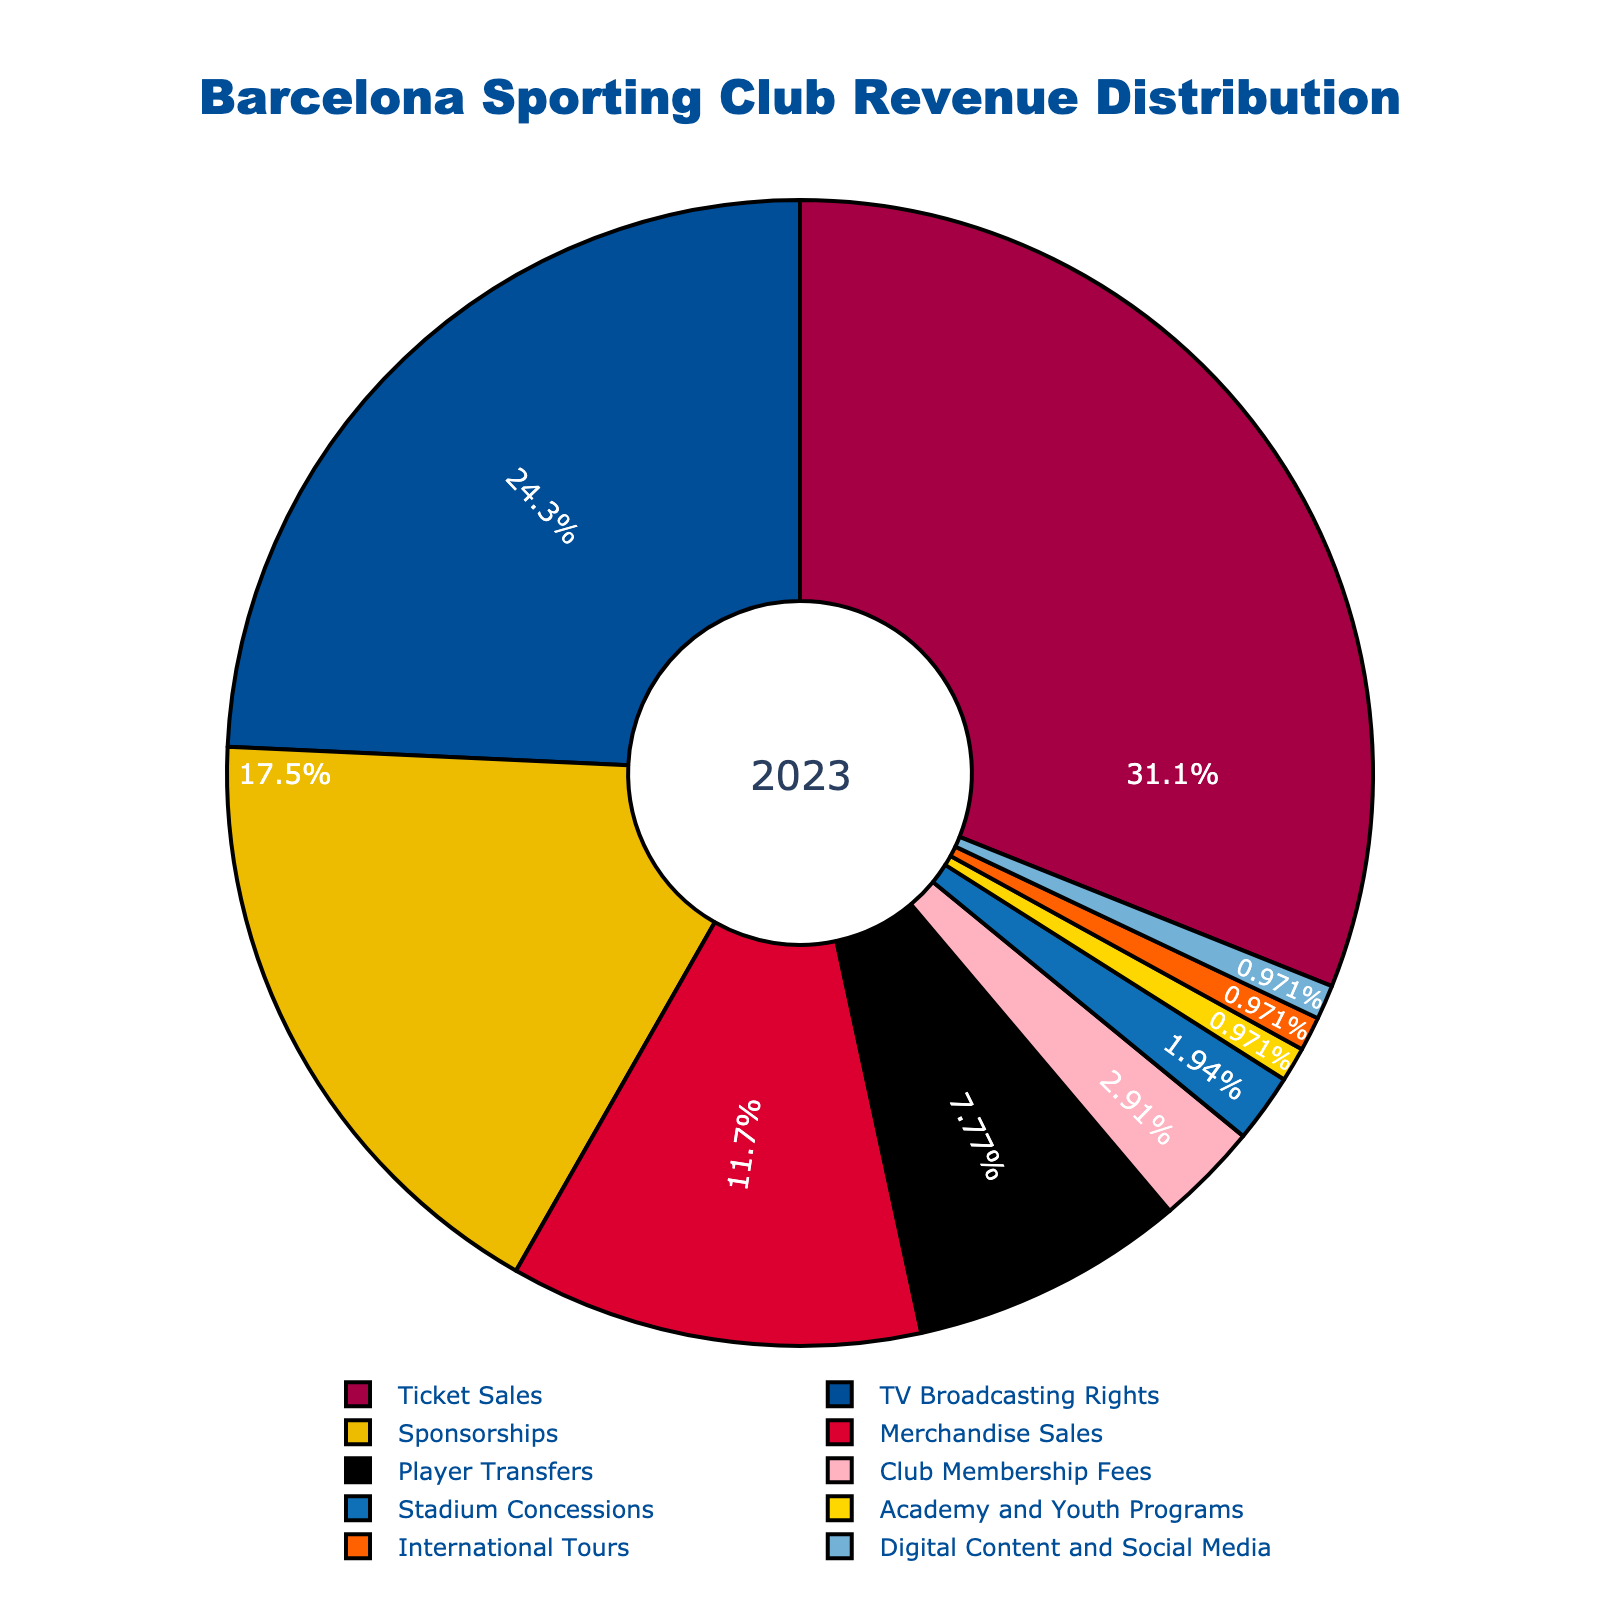Which revenue source contributes the most to the total revenue? The chart shows that Ticket Sales has the largest section among all the revenue sources.
Answer: Ticket Sales By how much does the percentage of Ticket Sales exceed that of Merchandise Sales? Ticket Sales accounts for 32%, while Merchandise Sales accounts for 12%. The difference between these two is calculated as 32% - 12% = 20%.
Answer: 20% What percentage of revenue comes from Club Membership Fees, Stadium Concessions, Academy and Youth Programs, International Tours, and Digital Content and Social Media combined? Adding the percentages for Club Membership Fees (3%), Stadium Concessions (2%), Academy and Youth Programs (1%), International Tours (1%), and Digital Content and Social Media (1%): 3% + 2% + 1% + 1% + 1% = 8%.
Answer: 8% Which two revenue sources have the closest percentages? Player Transfers and Club Membership Fees are the closest, with Player Transfers at 8% and Club Membership Fees at 3%, a difference of only 5%.
Answer: Player Transfers and Club Membership Fees What is the total percentage of revenue coming from TV Broadcasting Rights and Sponsorships? TV Broadcasting Rights contribute 25% and Sponsorships contribute 18%. Adding these two gives 25% + 18% = 43%.
Answer: 43% Which revenue source contributes the least, and what is its percentage? The chart indicates that Academy and Youth Programs, International Tours, and Digital Content and Social Media each contribute the least, at 1%.
Answer: Academy and Youth Programs, International Tours, and Digital Content and Social Media (1%) How does the percentage of revenue from Sponsorships compare to that from Player Transfers? Sponsorships account for 18% and Player Transfers contribute 8%. Sponsorships have a larger percentage by 18% - 8% = 10%.
Answer: Sponsorships are 10% more If the total revenue is $100 million, how much revenue comes from TV Broadcasting Rights? TV Broadcasting Rights make up 25% of the total revenue. 25% of $100 million is calculated as 0.25 * 100 million = $25 million.
Answer: $25 million 